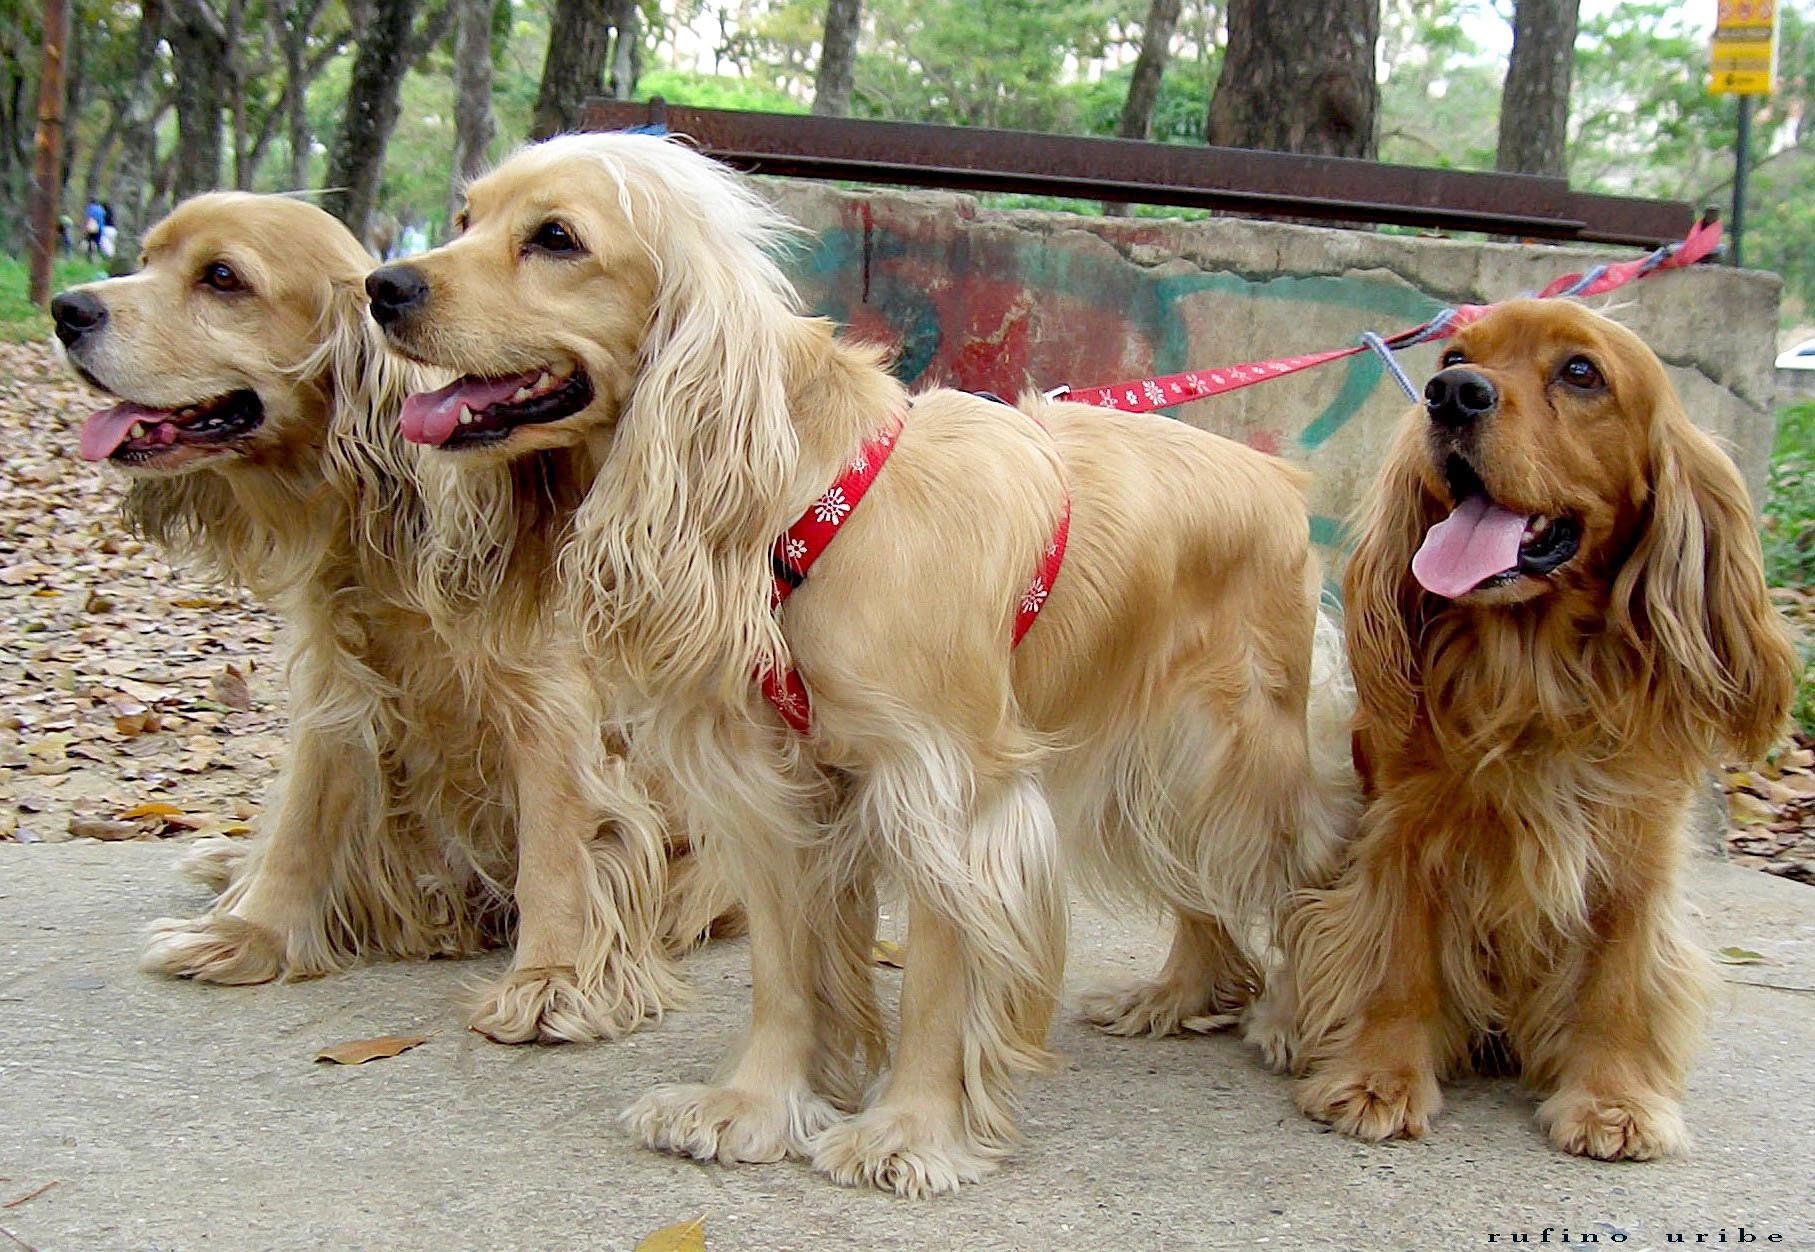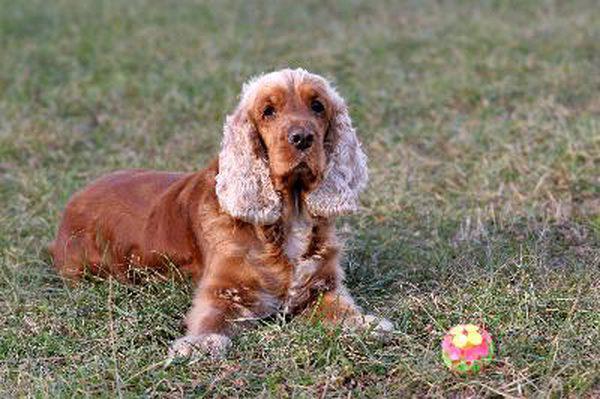The first image is the image on the left, the second image is the image on the right. For the images displayed, is the sentence "The dog in the image on the right is outside on the grass." factually correct? Answer yes or no. Yes. The first image is the image on the left, the second image is the image on the right. Analyze the images presented: Is the assertion "The left image includes exactly twice as many spaniel dogs as the right image." valid? Answer yes or no. No. 